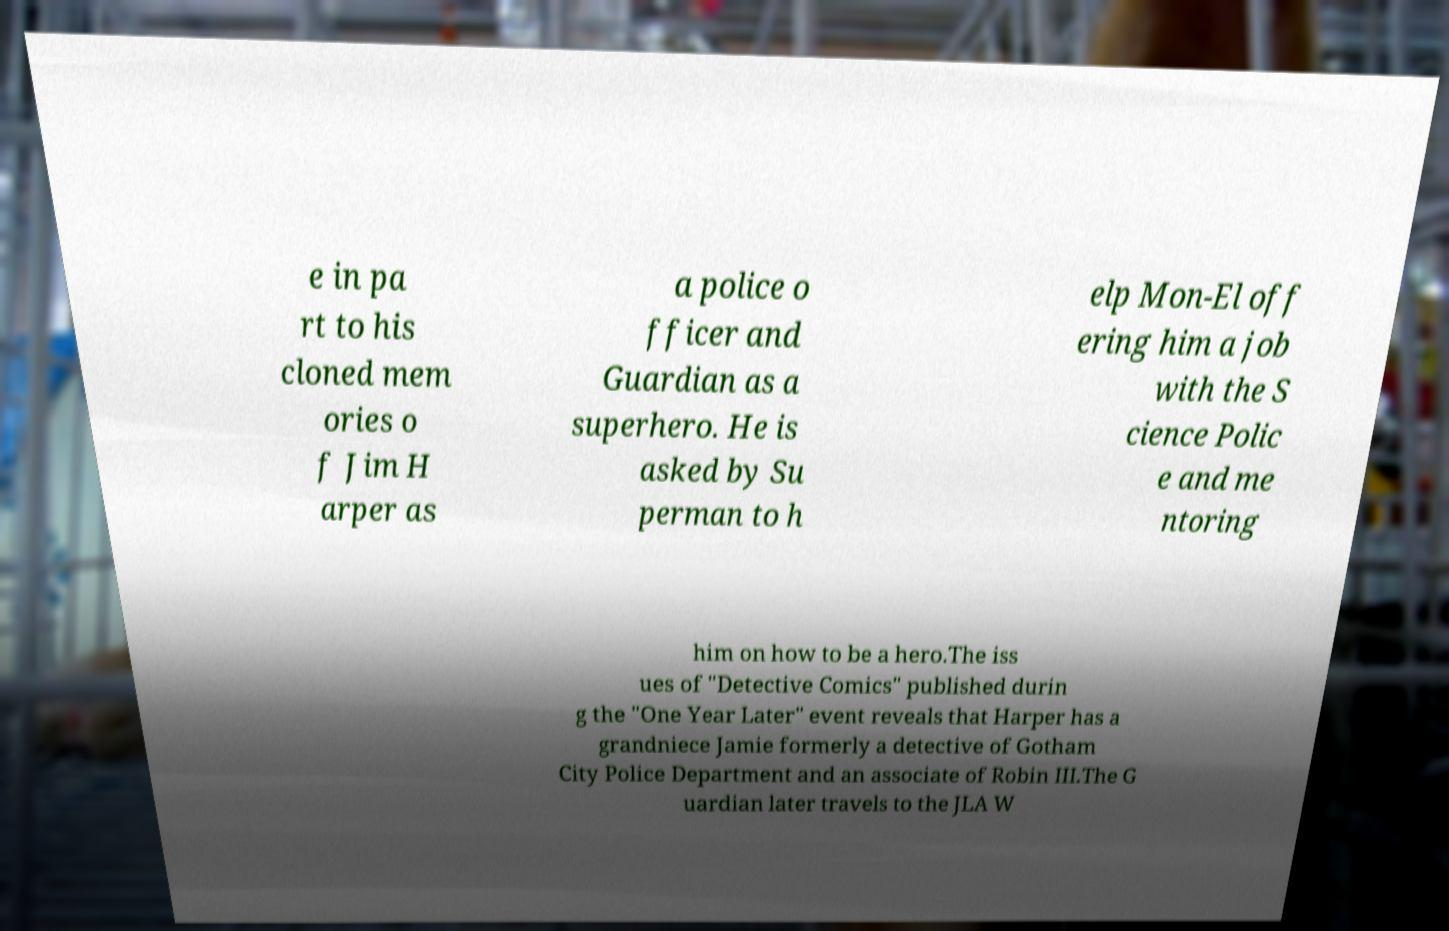Can you read and provide the text displayed in the image?This photo seems to have some interesting text. Can you extract and type it out for me? e in pa rt to his cloned mem ories o f Jim H arper as a police o fficer and Guardian as a superhero. He is asked by Su perman to h elp Mon-El off ering him a job with the S cience Polic e and me ntoring him on how to be a hero.The iss ues of "Detective Comics" published durin g the "One Year Later" event reveals that Harper has a grandniece Jamie formerly a detective of Gotham City Police Department and an associate of Robin III.The G uardian later travels to the JLA W 